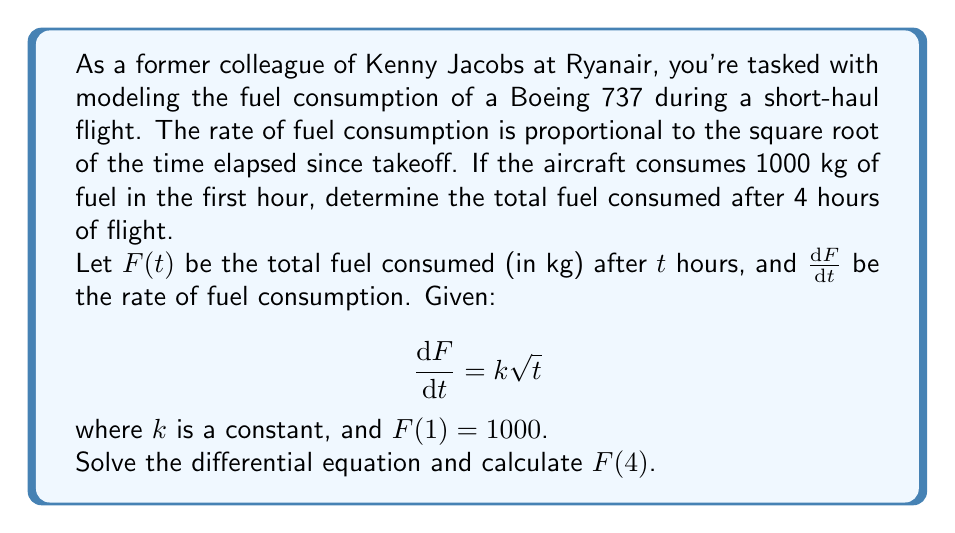Give your solution to this math problem. Let's solve this step-by-step:

1) First, we need to solve the differential equation:
   $$\frac{dF}{dt} = k\sqrt{t}$$

2) Integrate both sides:
   $$\int dF = k\int \sqrt{t} dt$$

3) Evaluate the integrals:
   $$F = k \cdot \frac{2}{3}t^{3/2} + C$$

4) Now we use the initial condition $F(1) = 1000$ to find $k$:
   $$1000 = k \cdot \frac{2}{3} \cdot 1^{3/2} + C$$
   $$1000 = \frac{2k}{3} + C$$

5) To eliminate $C$, we can use $F(0) = 0$ (no fuel consumed at takeoff):
   $$0 = k \cdot \frac{2}{3} \cdot 0^{3/2} + C$$
   $$C = 0$$

6) Substituting back into the equation from step 4:
   $$1000 = \frac{2k}{3}$$
   $$k = 1500$$

7) Our final equation for fuel consumption is:
   $$F(t) = 1000t^{3/2}$$

8) To find the fuel consumed after 4 hours, calculate $F(4)$:
   $$F(4) = 1000 \cdot 4^{3/2} = 1000 \cdot 8 = 8000$$

Therefore, after 4 hours of flight, the aircraft will have consumed 8000 kg of fuel.
Answer: $F(4) = 8000$ kg 